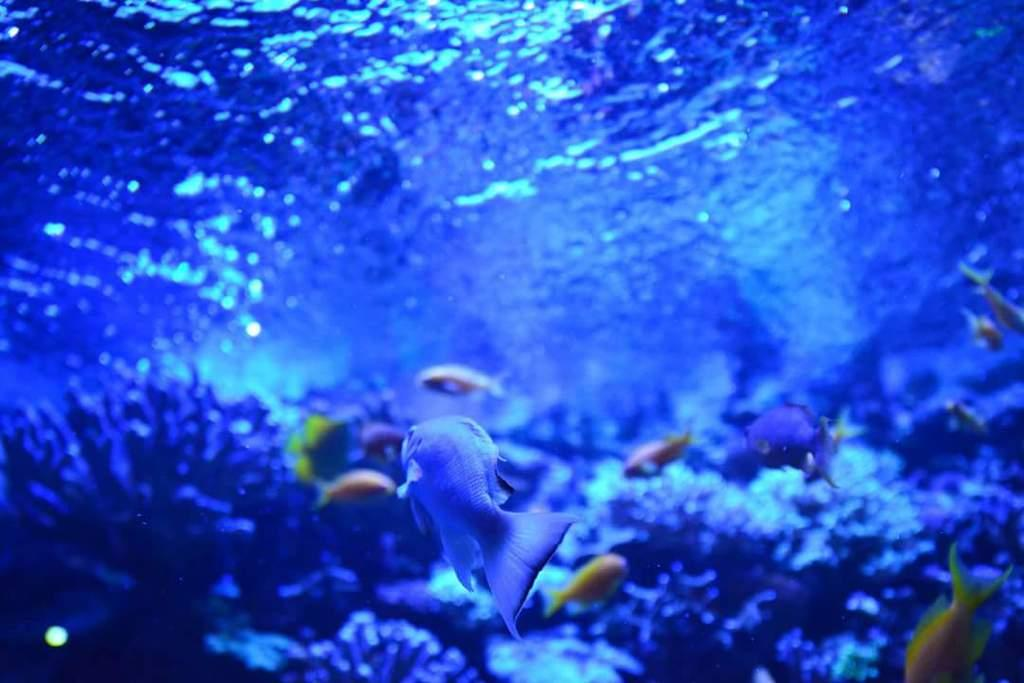Where is the image taken? The image is taken inside the water. What can be seen in the foreground of the image? There is a fish in the foreground of the image. What is present in the center of the image? There are multiple fishes and water plants in the center of the image. How many fingers can be seen touching the zinc in the image? There are no fingers or zinc present in the image; it features fish and water plants inside the water. 